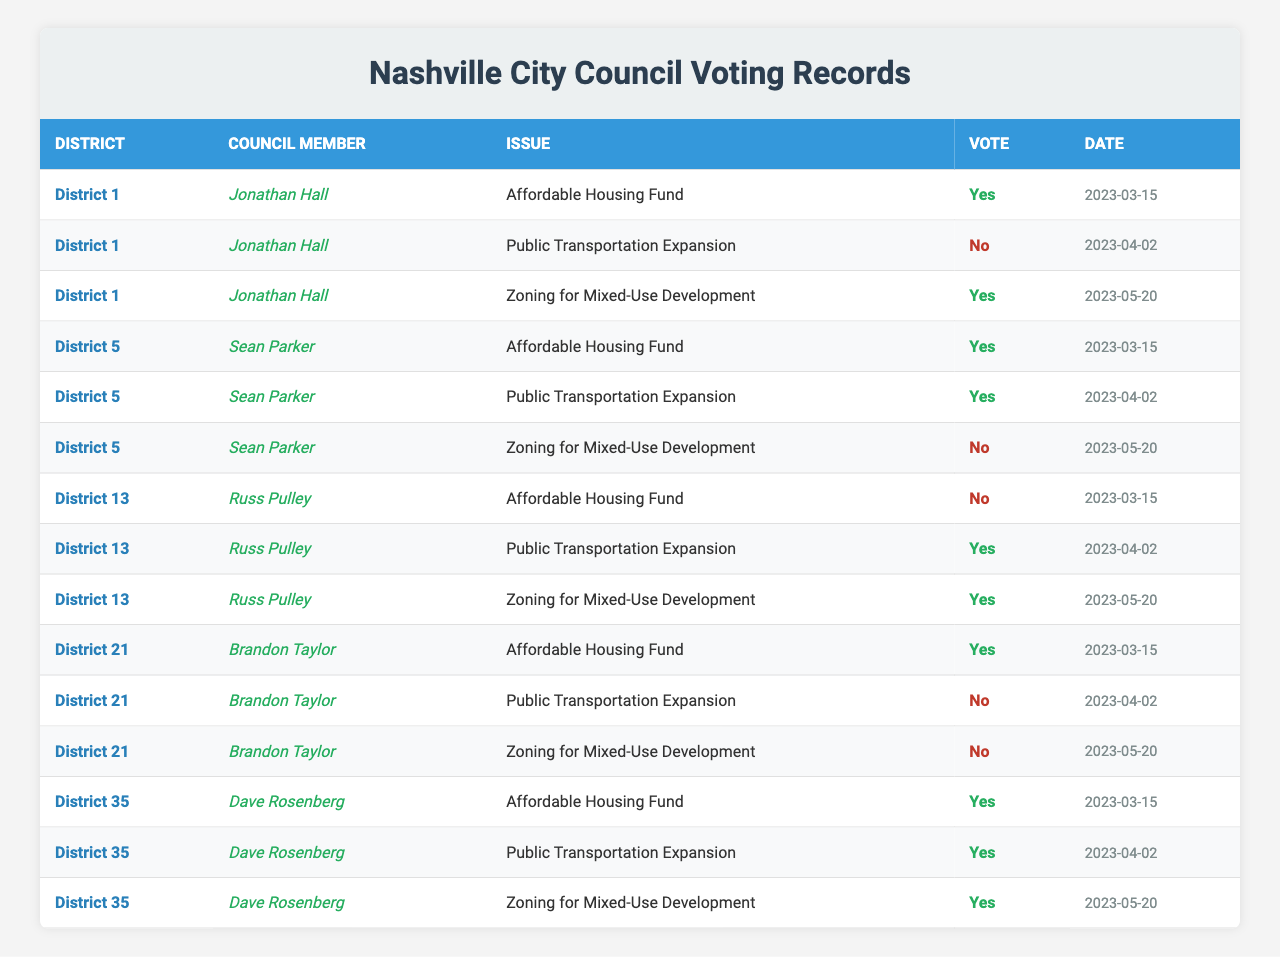What was the vote of Council Member Jonathan Hall on the Affordable Housing Fund? Council Member Jonathan Hall voted "Yes" on the Affordable Housing Fund. This information can be found in the row for District 1 under the specific issue.
Answer: Yes Which district had the highest number of "Yes" votes for the Zoning for Mixed-Use Development issue? District 35 had the highest number of "Yes" votes for the Zoning for Mixed-Use Development issue, as it is the only district that voted "Yes" for that issue.
Answer: District 35 Did all council members vote the same way on the Public Transportation Expansion issue? No, the votes varied: Jonathan Hall (No), Sean Parker (Yes), Russ Pulley (Yes), Brandon Taylor (No), and Dave Rosenberg (Yes). This discrepancy shows that not all members agreed on this issue.
Answer: No How many council members voted "Yes" on the Affordable Housing Fund? The council members voting "Yes" on the Affordable Housing Fund are Jonathan Hall, Sean Parker, Brandon Taylor, and Dave Rosenberg. This makes a total of 4 members voting "Yes."
Answer: 4 What is the total number of "No" votes across all council members for the Zoning for Mixed-Use Development issue? The "No" votes for the Zoning for Mixed-Use Development were cast by Sean Parker, Brandon Taylor, and Jonathan Hall, totaling 3 "No" votes.
Answer: 3 Which issue received the most "Yes" votes and how many? The issue that received the most "Yes" votes is the Affordable Housing Fund, with a total of 4 "Yes" votes from Jonathan Hall, Sean Parker, Brandon Taylor, and Dave Rosenberg.
Answer: 4 For which issue did the most council members vote "Yes"? The Affordable Housing Fund had the most "Yes" votes, with 4 members voting in favor, compared to other issues which had fewer "Yes" votes.
Answer: Affordable Housing Fund What percentage of votes were "Yes" for the Public Transportation Expansion issue? The votes were as follows: 3 "Yes" and 2 "No" which gives a percentage of (3/(3+2)) * 100 = 60% for "Yes" votes.
Answer: 60% Did any council member vote differently on the same issues? Yes, for the Public Transportation Expansion issue, Jonathan Hall and Brandon Taylor voted "No" while the others voted "Yes." This indicates differing opinions on the same issue.
Answer: Yes Compare the voting patterns of Districts 5 and 21 on the Public Transportation Expansion issue. District 5 voted "Yes" while District 21 voted "No" on the Public Transportation Expansion issue. This shows a clear difference in opinion between the two districts on this issue.
Answer: Different votes (Yes for District 5, No for District 21) 